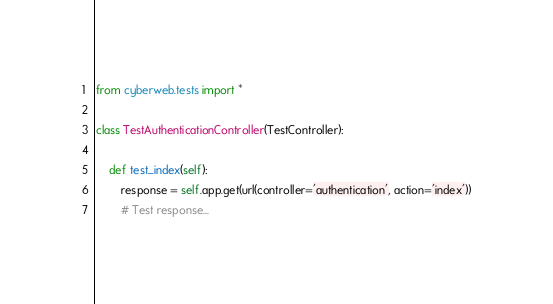<code> <loc_0><loc_0><loc_500><loc_500><_Python_>from cyberweb.tests import *

class TestAuthenticationController(TestController):

    def test_index(self):
        response = self.app.get(url(controller='authentication', action='index'))
        # Test response...
</code> 